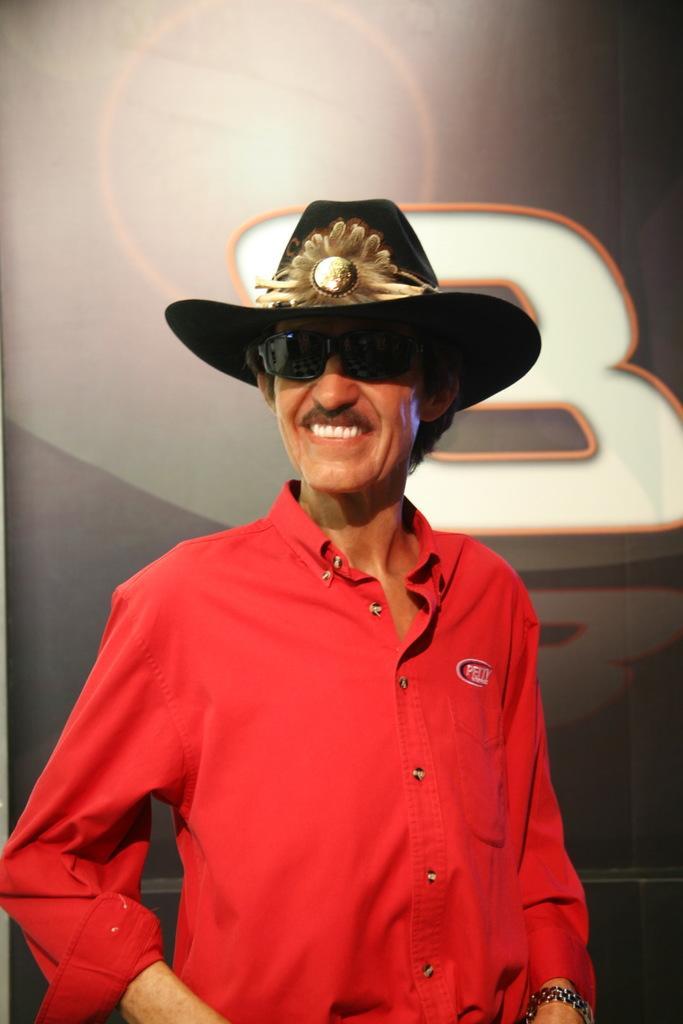In one or two sentences, can you explain what this image depicts? In this image, at the middle there is a man standing, he is wearing a red color shirt and he is wearing a hat and black color specs, at the background there is a poster. 